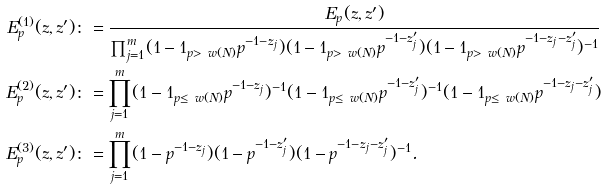Convert formula to latex. <formula><loc_0><loc_0><loc_500><loc_500>E _ { p } ^ { ( 1 ) } ( z , z ^ { \prime } ) & \colon = \frac { E _ { p } ( z , z ^ { \prime } ) } { \prod _ { j = 1 } ^ { m } ( 1 - { 1 } _ { p > \ w ( N ) } p ^ { - 1 - z _ { j } } ) ( 1 - { 1 } _ { p > \ w ( N ) } p ^ { - 1 - z ^ { \prime } _ { j } } ) ( 1 - { 1 } _ { p > \ w ( N ) } p ^ { - 1 - z _ { j } - z ^ { \prime } _ { j } } ) ^ { - 1 } } \\ E _ { p } ^ { ( 2 ) } ( z , z ^ { \prime } ) & \colon = \prod _ { j = 1 } ^ { m } ( 1 - { 1 } _ { p \leq \ w ( N ) } p ^ { - 1 - z _ { j } } ) ^ { - 1 } ( 1 - { 1 } _ { p \leq \ w ( N ) } p ^ { - 1 - z ^ { \prime } _ { j } } ) ^ { - 1 } ( 1 - { 1 } _ { p \leq \ w ( N ) } p ^ { - 1 - z _ { j } - z ^ { \prime } _ { j } } ) \\ E _ { p } ^ { ( 3 ) } ( z , z ^ { \prime } ) & \colon = \prod _ { j = 1 } ^ { m } ( 1 - p ^ { - 1 - z _ { j } } ) ( 1 - p ^ { - 1 - z ^ { \prime } _ { j } } ) ( 1 - p ^ { - 1 - z _ { j } - z ^ { \prime } _ { j } } ) ^ { - 1 } .</formula> 